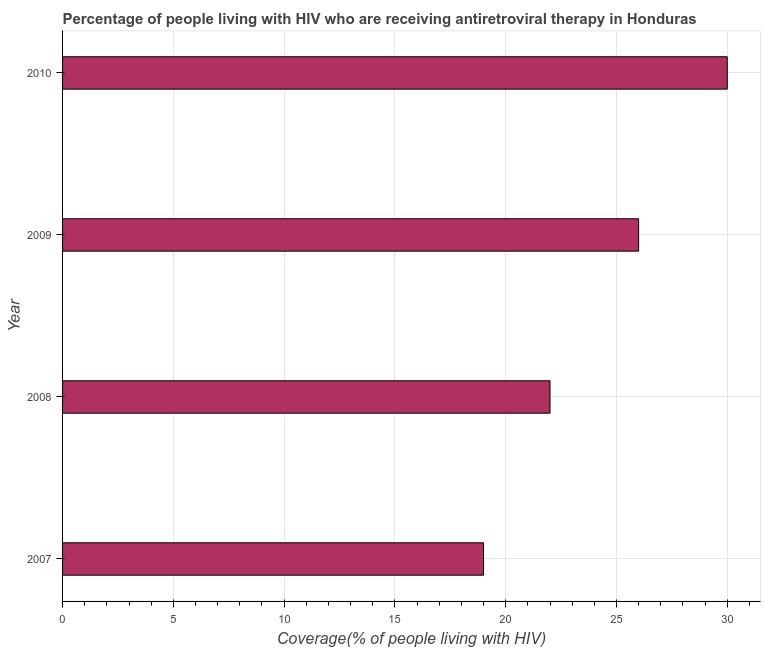Does the graph contain grids?
Provide a succinct answer. Yes. What is the title of the graph?
Keep it short and to the point. Percentage of people living with HIV who are receiving antiretroviral therapy in Honduras. What is the label or title of the X-axis?
Provide a short and direct response. Coverage(% of people living with HIV). What is the label or title of the Y-axis?
Your response must be concise. Year. What is the antiretroviral therapy coverage in 2007?
Provide a succinct answer. 19. In which year was the antiretroviral therapy coverage maximum?
Your response must be concise. 2010. What is the sum of the antiretroviral therapy coverage?
Ensure brevity in your answer.  97. What is the median antiretroviral therapy coverage?
Your answer should be very brief. 24. In how many years, is the antiretroviral therapy coverage greater than 11 %?
Provide a succinct answer. 4. What is the ratio of the antiretroviral therapy coverage in 2007 to that in 2010?
Ensure brevity in your answer.  0.63. Is the antiretroviral therapy coverage in 2008 less than that in 2009?
Your answer should be compact. Yes. Is the sum of the antiretroviral therapy coverage in 2007 and 2009 greater than the maximum antiretroviral therapy coverage across all years?
Your answer should be compact. Yes. How many bars are there?
Provide a short and direct response. 4. How many years are there in the graph?
Offer a very short reply. 4. What is the difference between two consecutive major ticks on the X-axis?
Provide a short and direct response. 5. What is the Coverage(% of people living with HIV) of 2010?
Offer a terse response. 30. What is the difference between the Coverage(% of people living with HIV) in 2007 and 2008?
Ensure brevity in your answer.  -3. What is the difference between the Coverage(% of people living with HIV) in 2007 and 2009?
Your response must be concise. -7. What is the difference between the Coverage(% of people living with HIV) in 2007 and 2010?
Offer a terse response. -11. What is the ratio of the Coverage(% of people living with HIV) in 2007 to that in 2008?
Give a very brief answer. 0.86. What is the ratio of the Coverage(% of people living with HIV) in 2007 to that in 2009?
Give a very brief answer. 0.73. What is the ratio of the Coverage(% of people living with HIV) in 2007 to that in 2010?
Your answer should be compact. 0.63. What is the ratio of the Coverage(% of people living with HIV) in 2008 to that in 2009?
Provide a short and direct response. 0.85. What is the ratio of the Coverage(% of people living with HIV) in 2008 to that in 2010?
Make the answer very short. 0.73. What is the ratio of the Coverage(% of people living with HIV) in 2009 to that in 2010?
Ensure brevity in your answer.  0.87. 